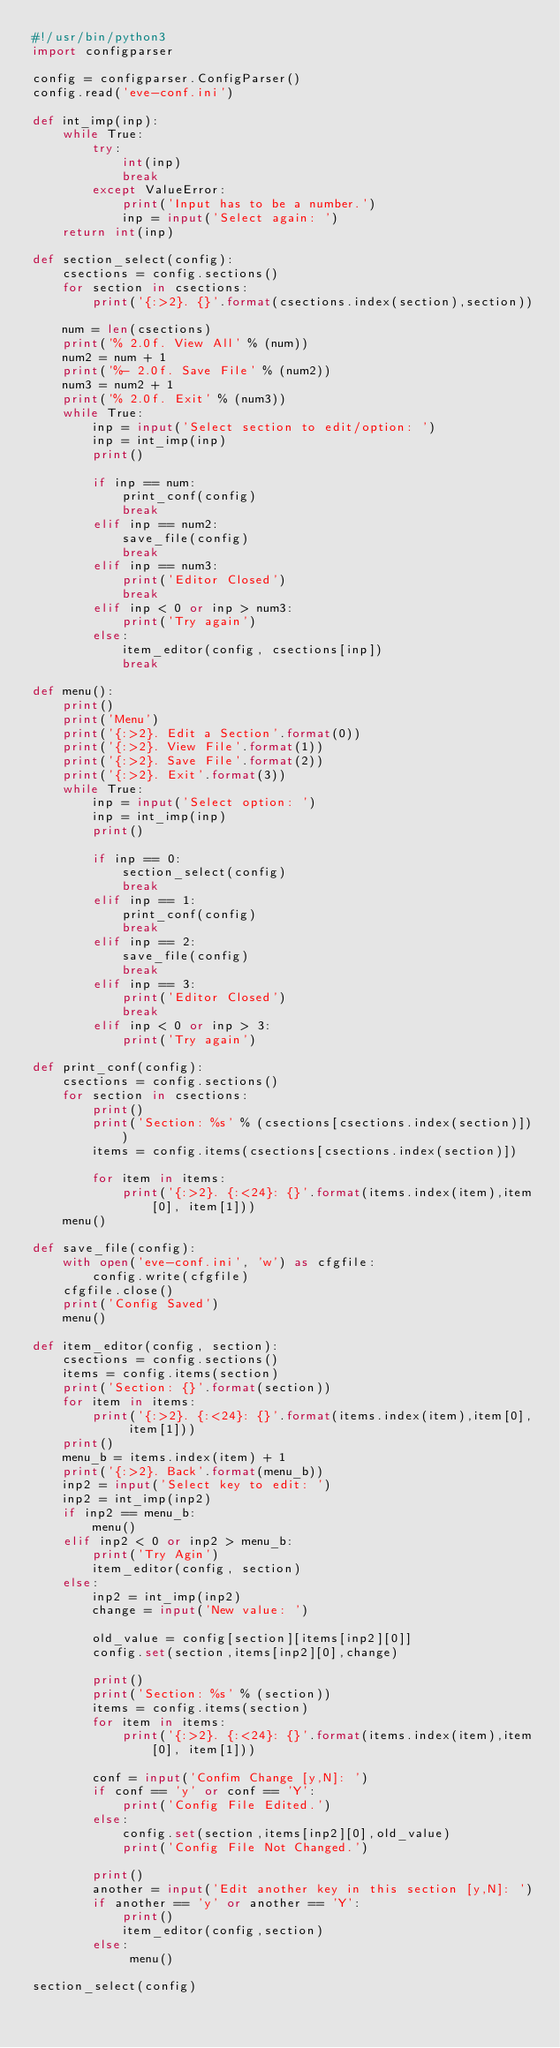Convert code to text. <code><loc_0><loc_0><loc_500><loc_500><_Python_>#!/usr/bin/python3
import configparser

config = configparser.ConfigParser()
config.read('eve-conf.ini')

def int_imp(inp):
    while True:
        try:
            int(inp)
            break
        except ValueError:
            print('Input has to be a number.')
            inp = input('Select again: ')
    return int(inp)

def section_select(config):
    csections = config.sections()
    for section in csections:
        print('{:>2}. {}'.format(csections.index(section),section))

    num = len(csections)
    print('% 2.0f. View All' % (num))
    num2 = num + 1
    print('%- 2.0f. Save File' % (num2))
    num3 = num2 + 1
    print('% 2.0f. Exit' % (num3))
    while True:
        inp = input('Select section to edit/option: ')
        inp = int_imp(inp)
        print()

        if inp == num:
            print_conf(config)
            break
        elif inp == num2:
            save_file(config)
            break
        elif inp == num3:
            print('Editor Closed')
            break
        elif inp < 0 or inp > num3:
            print('Try again')
        else:
            item_editor(config, csections[inp])
            break

def menu():
    print()
    print('Menu')
    print('{:>2}. Edit a Section'.format(0))
    print('{:>2}. View File'.format(1))
    print('{:>2}. Save File'.format(2))
    print('{:>2}. Exit'.format(3))
    while True:
        inp = input('Select option: ')
        inp = int_imp(inp)
        print()

        if inp == 0:
            section_select(config)
            break
        elif inp == 1:
            print_conf(config)
            break
        elif inp == 2:
            save_file(config)
            break
        elif inp == 3:
            print('Editor Closed')
            break
        elif inp < 0 or inp > 3:
            print('Try again')

def print_conf(config):
    csections = config.sections()
    for section in csections:
        print()
        print('Section: %s' % (csections[csections.index(section)]))
        items = config.items(csections[csections.index(section)])

        for item in items:
            print('{:>2}. {:<24}: {}'.format(items.index(item),item[0], item[1]))
    menu()

def save_file(config):
    with open('eve-conf.ini', 'w') as cfgfile:
        config.write(cfgfile)
    cfgfile.close()
    print('Config Saved')
    menu()

def item_editor(config, section):
    csections = config.sections()
    items = config.items(section)
    print('Section: {}'.format(section))
    for item in items:
        print('{:>2}. {:<24}: {}'.format(items.index(item),item[0], item[1]))
    print()
    menu_b = items.index(item) + 1
    print('{:>2}. Back'.format(menu_b))
    inp2 = input('Select key to edit: ')
    inp2 = int_imp(inp2)
    if inp2 == menu_b:
        menu()
    elif inp2 < 0 or inp2 > menu_b:
        print('Try Agin')
        item_editor(config, section)
    else:
        inp2 = int_imp(inp2)
        change = input('New value: ')

        old_value = config[section][items[inp2][0]]
        config.set(section,items[inp2][0],change)

        print()
        print('Section: %s' % (section))
        items = config.items(section)
        for item in items:
            print('{:>2}. {:<24}: {}'.format(items.index(item),item[0], item[1]))

        conf = input('Confim Change [y,N]: ')
        if conf == 'y' or conf == 'Y':
            print('Config File Edited.')
        else:
            config.set(section,items[inp2][0],old_value)
            print('Config File Not Changed.')

        print()
        another = input('Edit another key in this section [y,N]: ')
        if another == 'y' or another == 'Y':
            print()
            item_editor(config,section)
        else:
             menu()

section_select(config)
</code> 